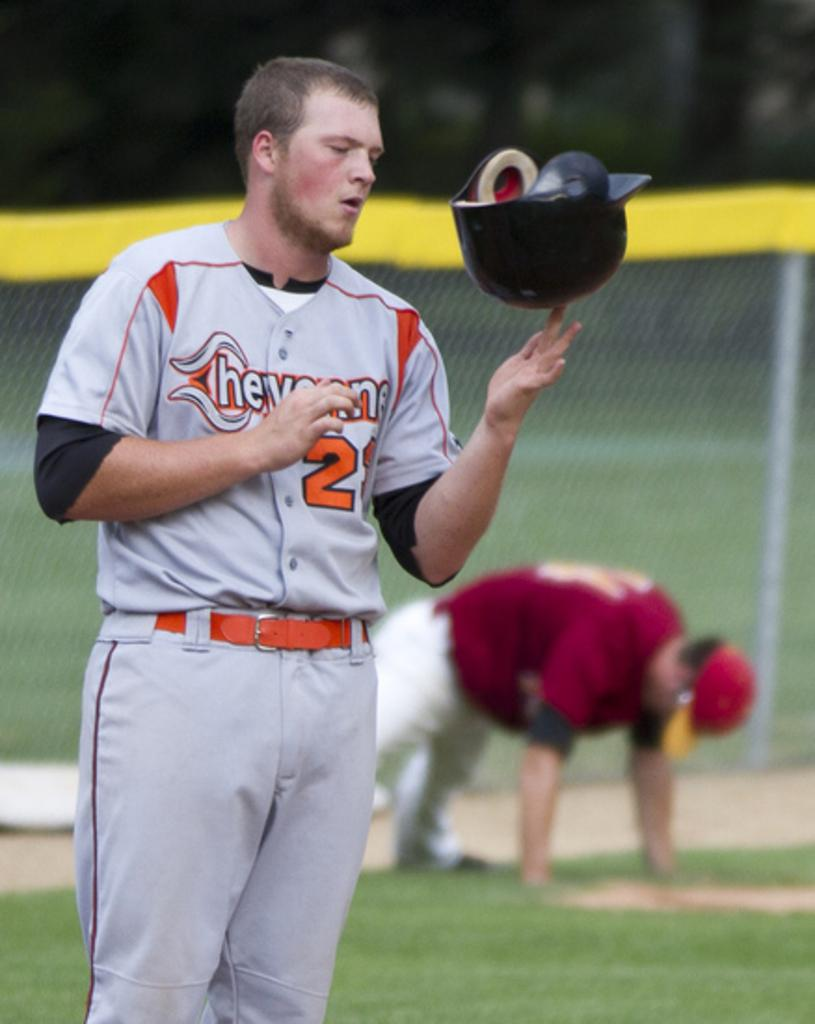Provide a one-sentence caption for the provided image. Player number 2 is spinning his batting helmet on one finger. 